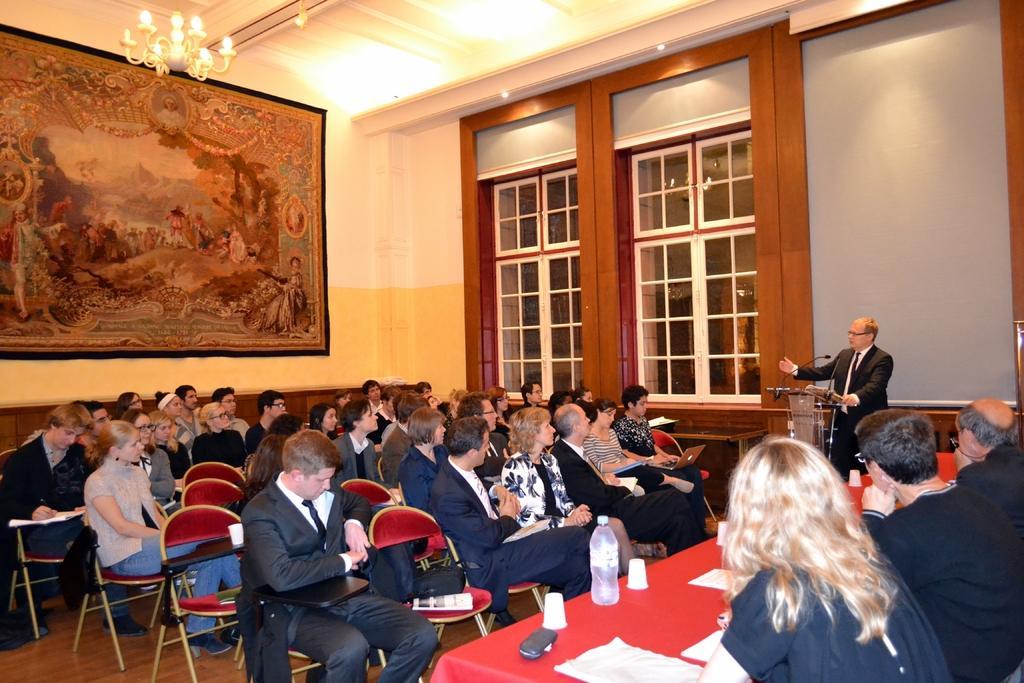How would you summarize this image in a sentence or two? This picture shows a group of people seated on the chairs and we see a photo frame on the wall and we see a chandelier light and we see water bottles and cups and some papers on the table and we see few people seated on the other side of the table and a man speaking at a podium with the help of a microphone 